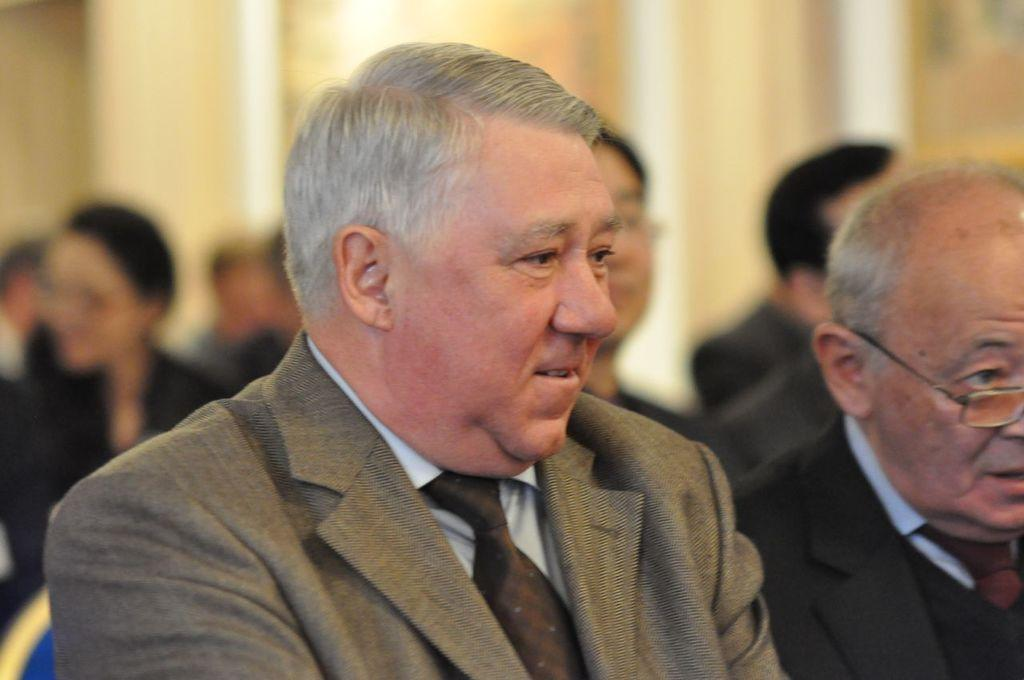How many people are in the foreground of the image? There are two persons in the foreground of the image. What can be seen in the background of the image? There is a group of people in the background of the image, and it appears to be a wall. Can you describe the people in the foreground? The provided facts do not give specific details about the appearance or actions of the two persons in the foreground. Is the quicksand visible in the image? There is no quicksand present in the image. What type of jam is being served to the family in the image? There is no mention of jam or a family in the image. 